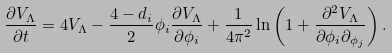Convert formula to latex. <formula><loc_0><loc_0><loc_500><loc_500>\frac { \partial V _ { \Lambda } } { \partial t } = 4 V _ { \Lambda } - \frac { 4 - d _ { i } } { 2 } \phi _ { i } \frac { \partial V _ { \Lambda } } { \partial \phi _ { i } } + \frac { 1 } { 4 \pi ^ { 2 } } \ln \left ( 1 + \frac { \partial ^ { 2 } V _ { \Lambda } } { \partial \phi _ { i } \partial _ { \phi _ { j } } } \right ) .</formula> 